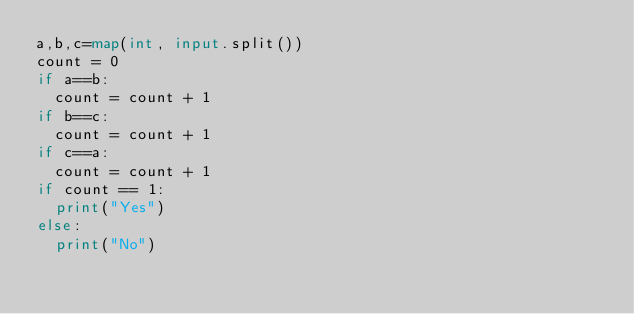Convert code to text. <code><loc_0><loc_0><loc_500><loc_500><_Python_>a,b,c=map(int, input.split())
count = 0
if a==b:
  count = count + 1
if b==c:
  count = count + 1
if c==a:
  count = count + 1
if count == 1:
  print("Yes")
else:
  print("No")</code> 